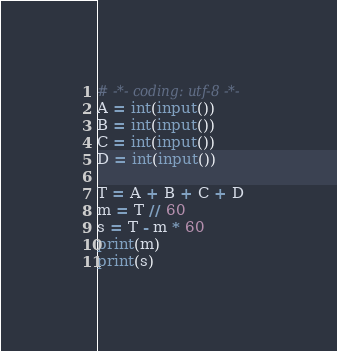<code> <loc_0><loc_0><loc_500><loc_500><_Python_># -*- coding: utf-8 -*-
A = int(input())
B = int(input())
C = int(input())
D = int(input())

T = A + B + C + D
m = T // 60
s = T - m * 60
print(m)
print(s)

</code> 